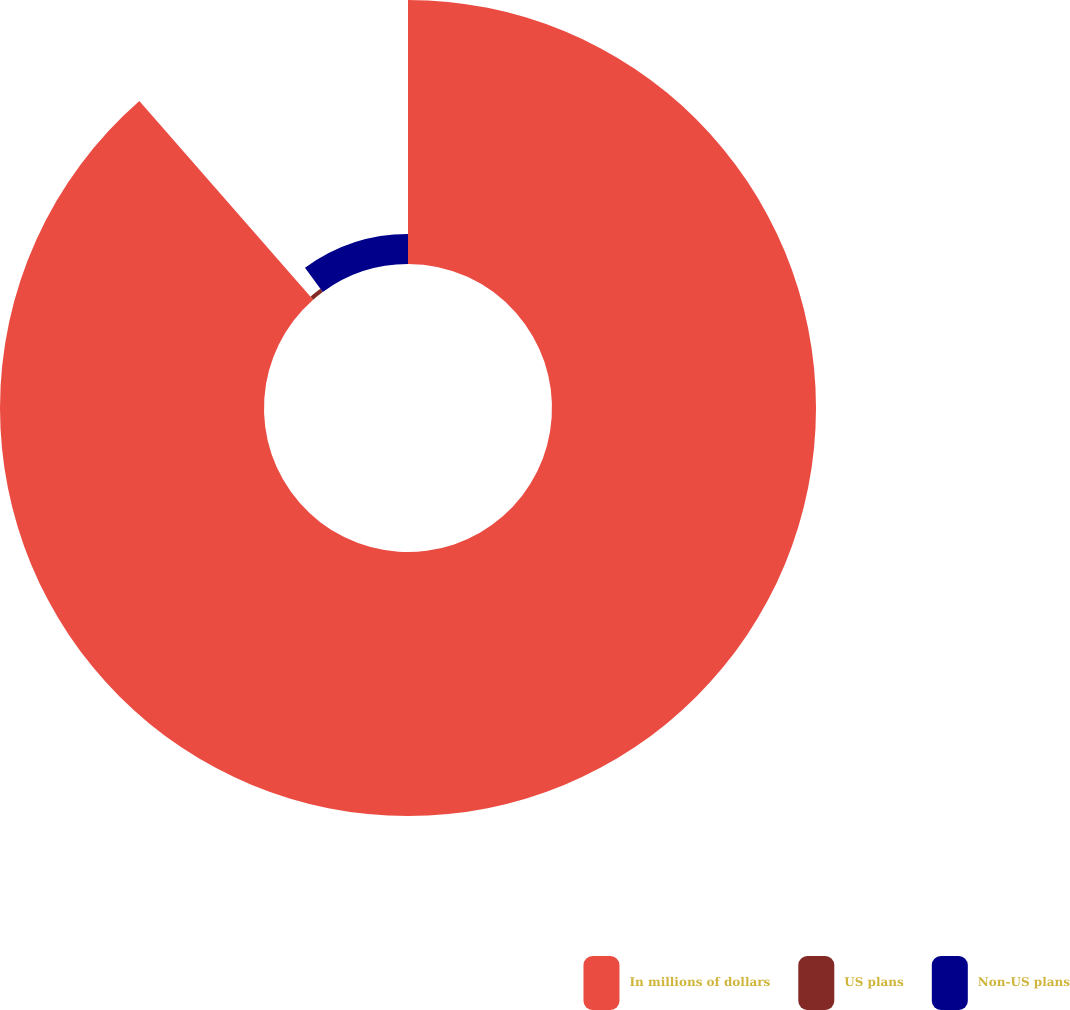Convert chart to OTSL. <chart><loc_0><loc_0><loc_500><loc_500><pie_chart><fcel>In millions of dollars<fcel>US plans<fcel>Non-US plans<nl><fcel>88.56%<fcel>1.36%<fcel>10.08%<nl></chart> 